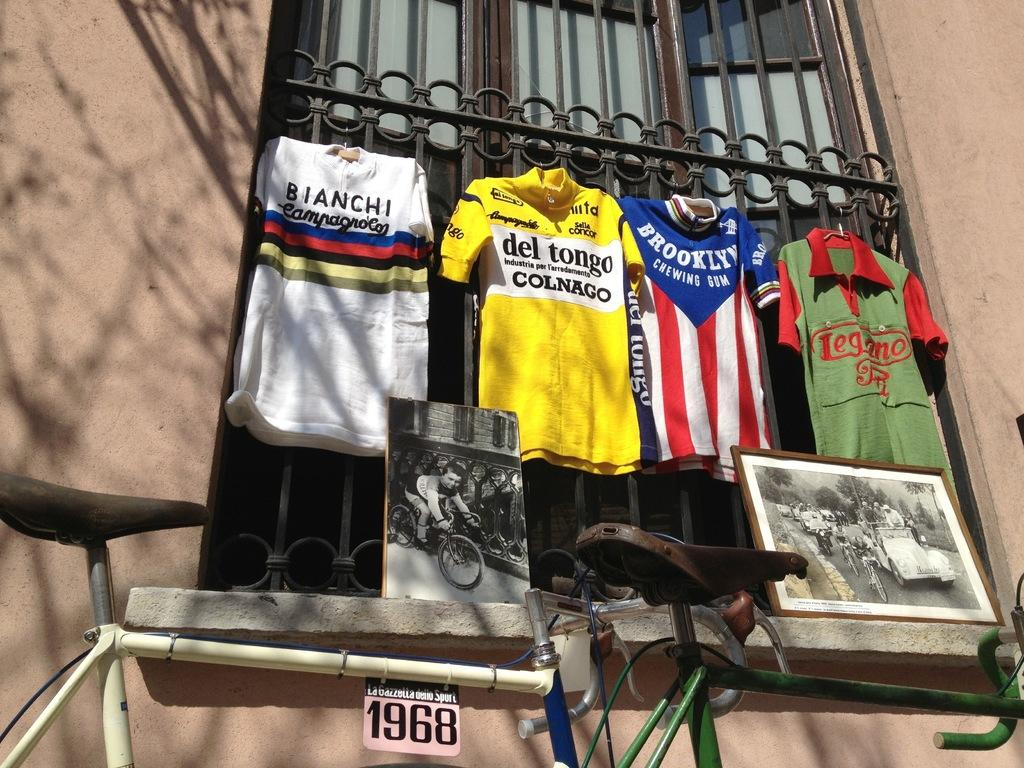What type of objects can be seen in the image? There are photo frames, t-shirts, bicycles, and some unspecified objects in the image. What type of structure is visible in the image? There is a window and a wall visible in the image. What type of weather can be seen in the image? There is no indication of weather in the image, as it focuses on objects and structures. What type of ball is being used in the image? There is no ball present in the image. 